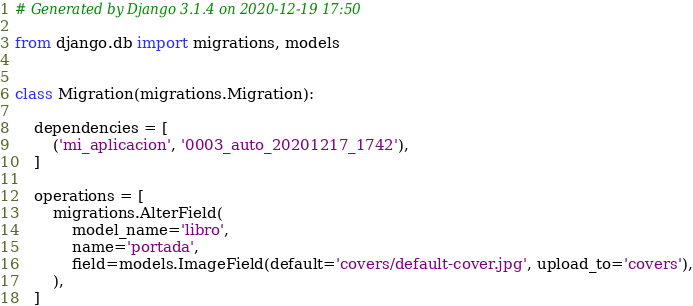Convert code to text. <code><loc_0><loc_0><loc_500><loc_500><_Python_># Generated by Django 3.1.4 on 2020-12-19 17:50

from django.db import migrations, models


class Migration(migrations.Migration):

    dependencies = [
        ('mi_aplicacion', '0003_auto_20201217_1742'),
    ]

    operations = [
        migrations.AlterField(
            model_name='libro',
            name='portada',
            field=models.ImageField(default='covers/default-cover.jpg', upload_to='covers'),
        ),
    ]
</code> 